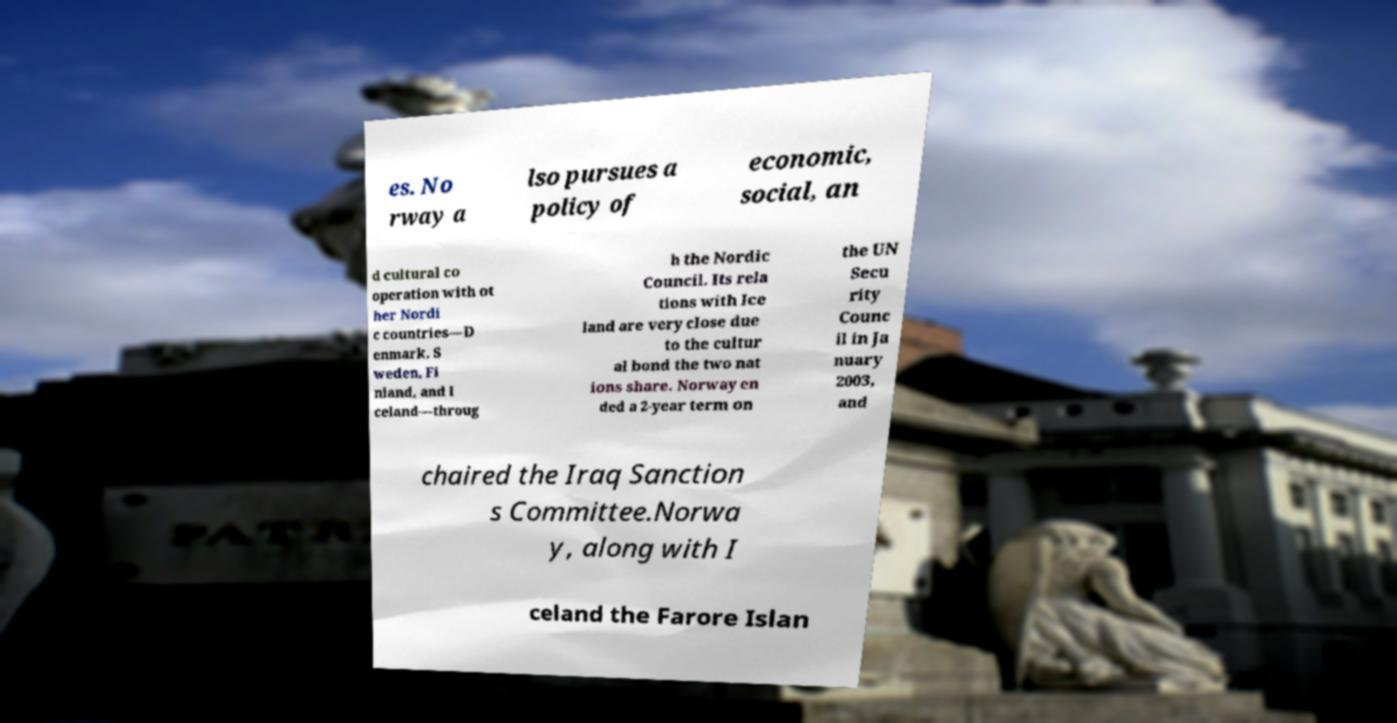There's text embedded in this image that I need extracted. Can you transcribe it verbatim? es. No rway a lso pursues a policy of economic, social, an d cultural co operation with ot her Nordi c countries—D enmark, S weden, Fi nland, and I celand—throug h the Nordic Council. Its rela tions with Ice land are very close due to the cultur al bond the two nat ions share. Norway en ded a 2-year term on the UN Secu rity Counc il in Ja nuary 2003, and chaired the Iraq Sanction s Committee.Norwa y, along with I celand the Farore Islan 